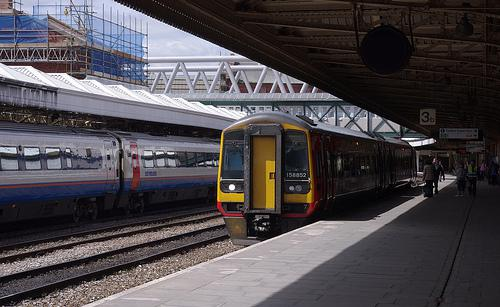Question: where are the tracks?
Choices:
A. Under the train.
B. Under the light rail.
C. Under the car.
D. Under the bus.
Answer with the letter. Answer: A Question: where is the bridge?
Choices:
A. Behind the cars.
B. Behind the buses.
C. Behind the scooters.
D. Behind the trains.
Answer with the letter. Answer: D Question: when was this taken?
Choices:
A. Night time.
B. Noon.
C. Morning.
D. Day time.
Answer with the letter. Answer: D Question: what type of vehicle is this?
Choices:
A. Train.
B. Car.
C. Bus.
D. Taxi.
Answer with the letter. Answer: A Question: what are the trains running on?
Choices:
A. Electricity.
B. Steam.
C. Tracks.
D. Coal.
Answer with the letter. Answer: C Question: what platform number?
Choices:
A. 4.
B. 3.
C. 2.
D. 1.
Answer with the letter. Answer: B Question: how many trains?
Choices:
A. One.
B. Three.
C. Two.
D. Four.
Answer with the letter. Answer: C 